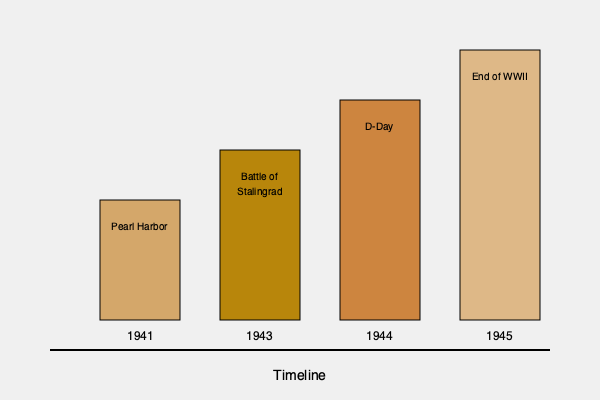Based on the timeline of postmarked envelopes from World War II, which year saw the most significant increase in correspondence volume, likely due to a major military operation? To determine the year with the most significant increase in correspondence volume, we need to analyze the heights of the rectangles representing each year, as they indicate the relative volume of letters:

1. 1941 (Pearl Harbor): The rectangle height is moderate, representing the start of US involvement in WWII.
2. 1943 (Battle of Stalingrad): The rectangle is taller than 1941, showing an increase in correspondence.
3. 1944 (D-Day): This rectangle is significantly taller than the previous years, indicating a substantial increase in letter volume.
4. 1945 (End of WWII): While this is the tallest rectangle, we're looking for the most significant increase, not the highest overall volume.

The most notable jump in height occurs between 1943 and 1944, coinciding with the D-Day operation. This suggests that 1944 saw the most significant increase in correspondence volume, likely due to the massive scale of the D-Day invasion and subsequent operations in Europe.
Answer: 1944 